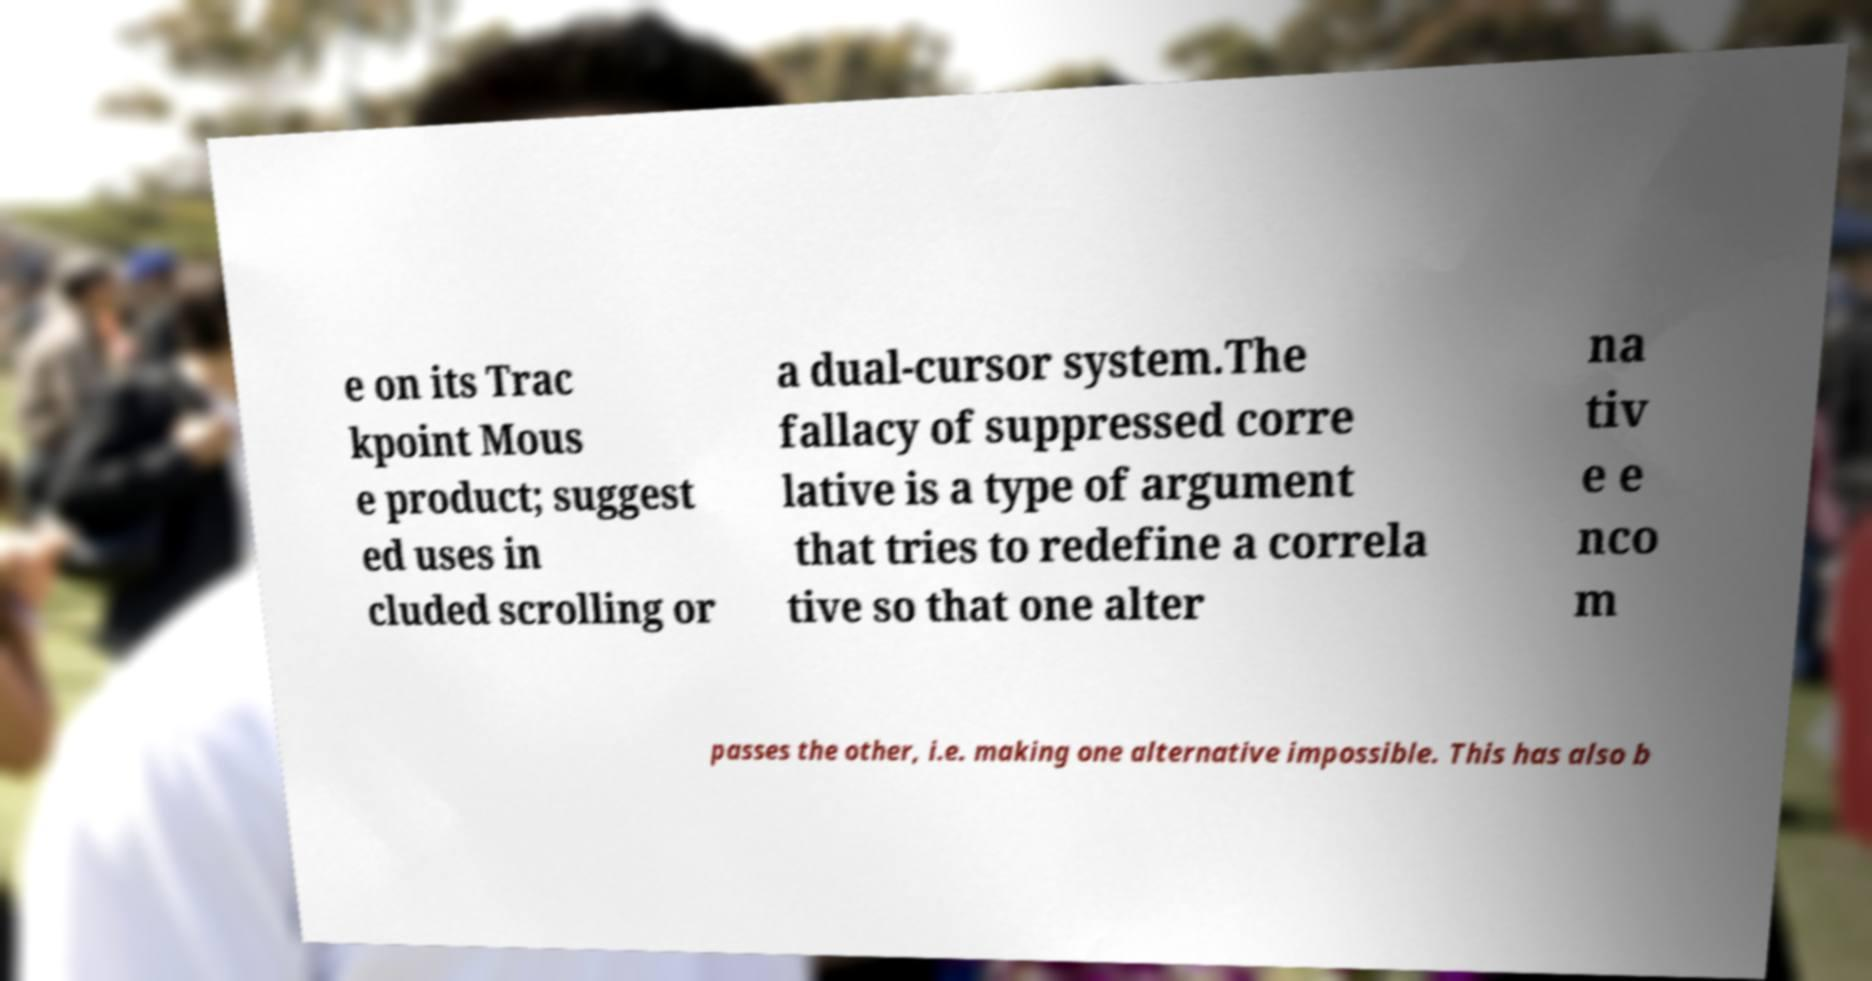What messages or text are displayed in this image? I need them in a readable, typed format. e on its Trac kpoint Mous e product; suggest ed uses in cluded scrolling or a dual-cursor system.The fallacy of suppressed corre lative is a type of argument that tries to redefine a correla tive so that one alter na tiv e e nco m passes the other, i.e. making one alternative impossible. This has also b 